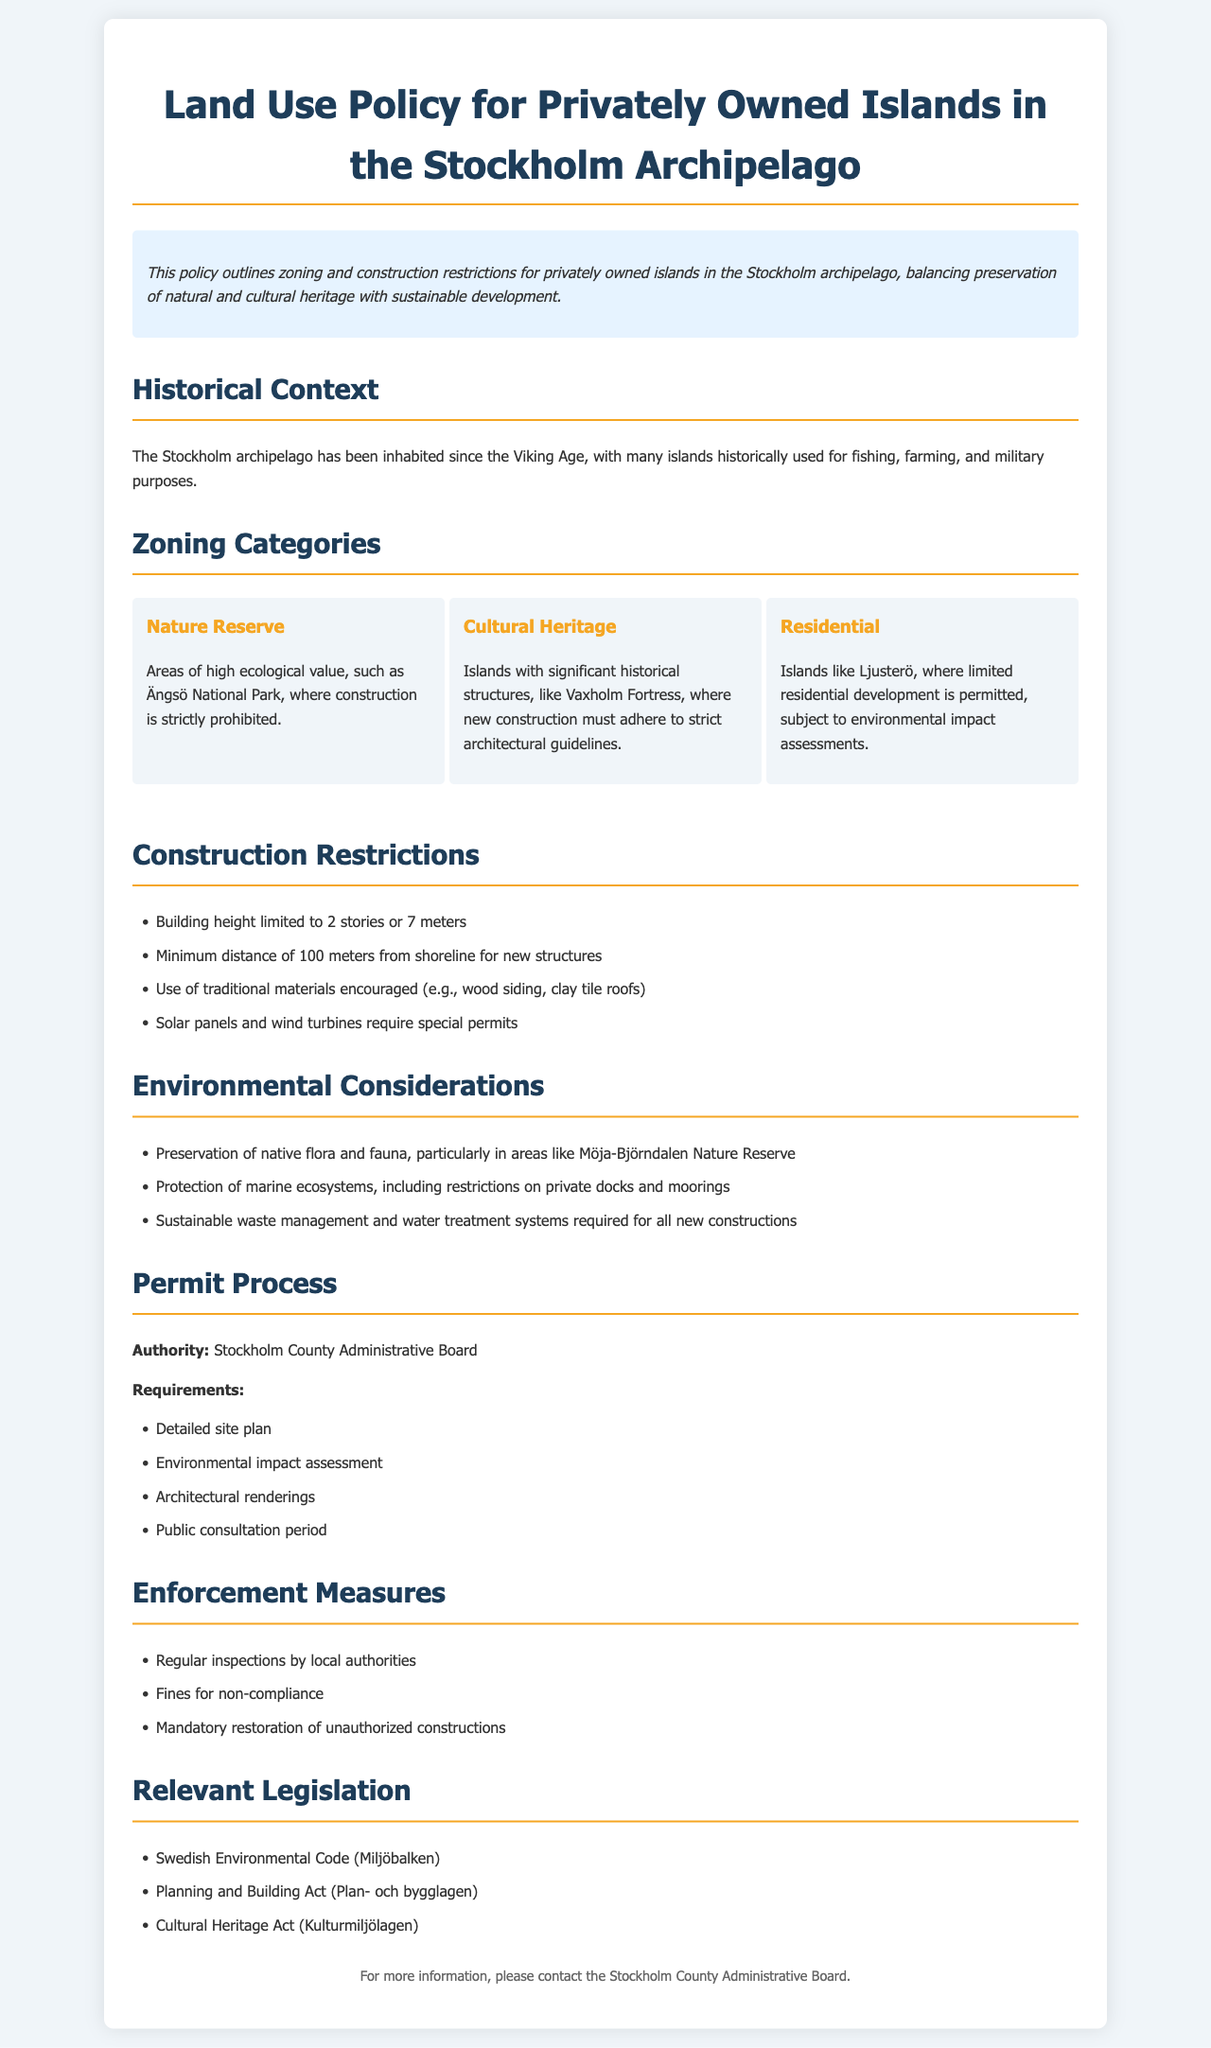what is the title of the policy? The title is explicitly stated at the beginning of the document.
Answer: Land Use Policy for Privately Owned Islands in the Stockholm Archipelago which island is an example of a Nature Reserve? The document provides an example of a Nature Reserve in the Zoning Categories section.
Answer: Ängsö National Park how many stories are allowed for buildings under the construction restrictions? This information is specified in the Construction Restrictions section of the document.
Answer: 2 stories what is the required minimum distance from the shoreline for new structures? The minimum distance for construction is listed in the Construction Restrictions.
Answer: 100 meters who is the authority responsible for the permit process? The document mentions the authority in the Permit Process section.
Answer: Stockholm County Administrative Board what kind of materials are encouraged for construction? The document specifies material preferences in the Construction Restrictions section.
Answer: traditional materials name one environmental consideration mentioned in the policy. The Environmental Considerations section lists various factors to consider.
Answer: Preservation of native flora and fauna what is a consequence of non-compliance with the policy? The document outlines enforcement measures, including consequences for violations.
Answer: Fines for non-compliance which law relates to cultural heritage in Sweden? The Relevant Legislation section includes specific laws pertaining to culture.
Answer: Cultural Heritage Act 